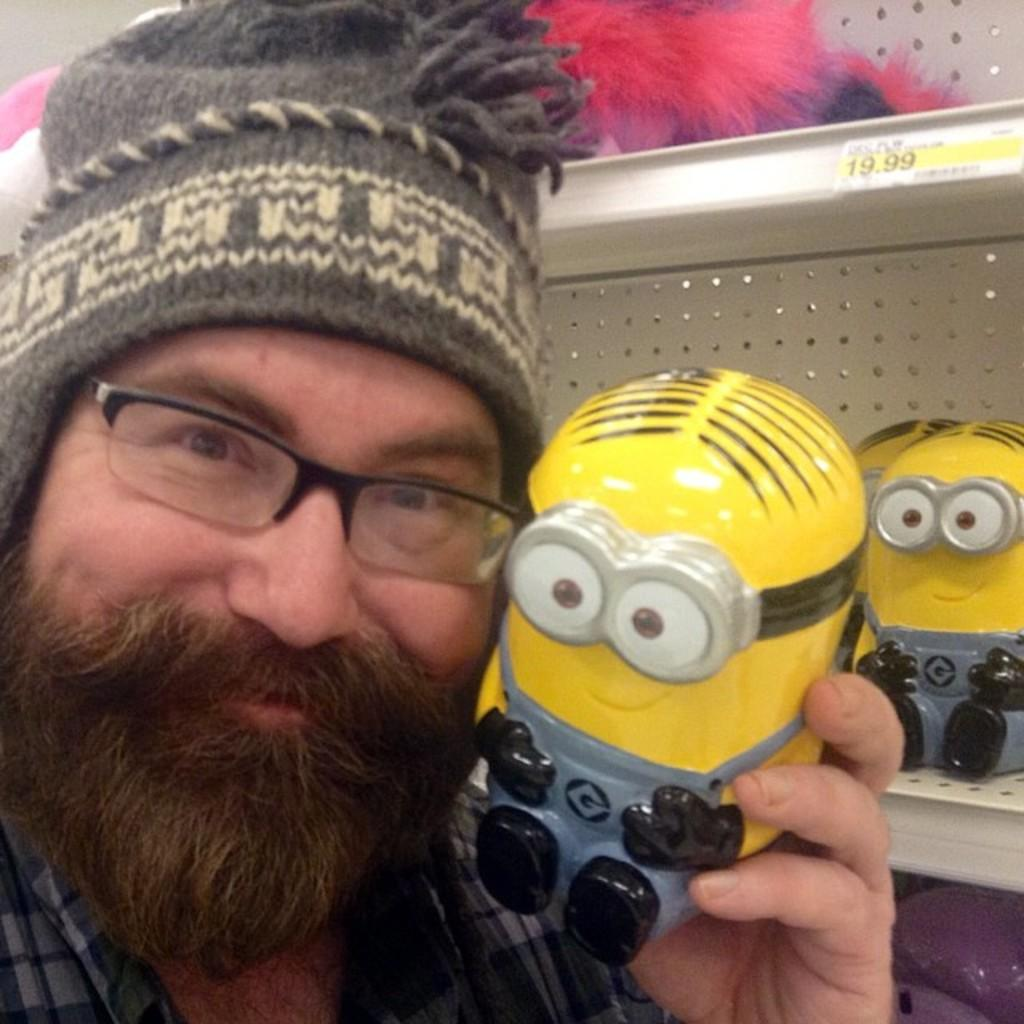What is located on the left side of the image? There is a man on the left side of the image. What is the man wearing on his head? The man is wearing a cap. What is the man doing in the image? The man is smiling and holding a toy. What can be seen in the background of the image? There are shelves in the background of the image, with toys and posters on them. What type of shoe is the man wearing in the image? The man is not wearing any shoes in the image; he is wearing a cap and a shirt. How does the man feel about his actions in the image? The man's feelings cannot be determined from the image, but he is smiling, which might suggest happiness or enjoyment. 